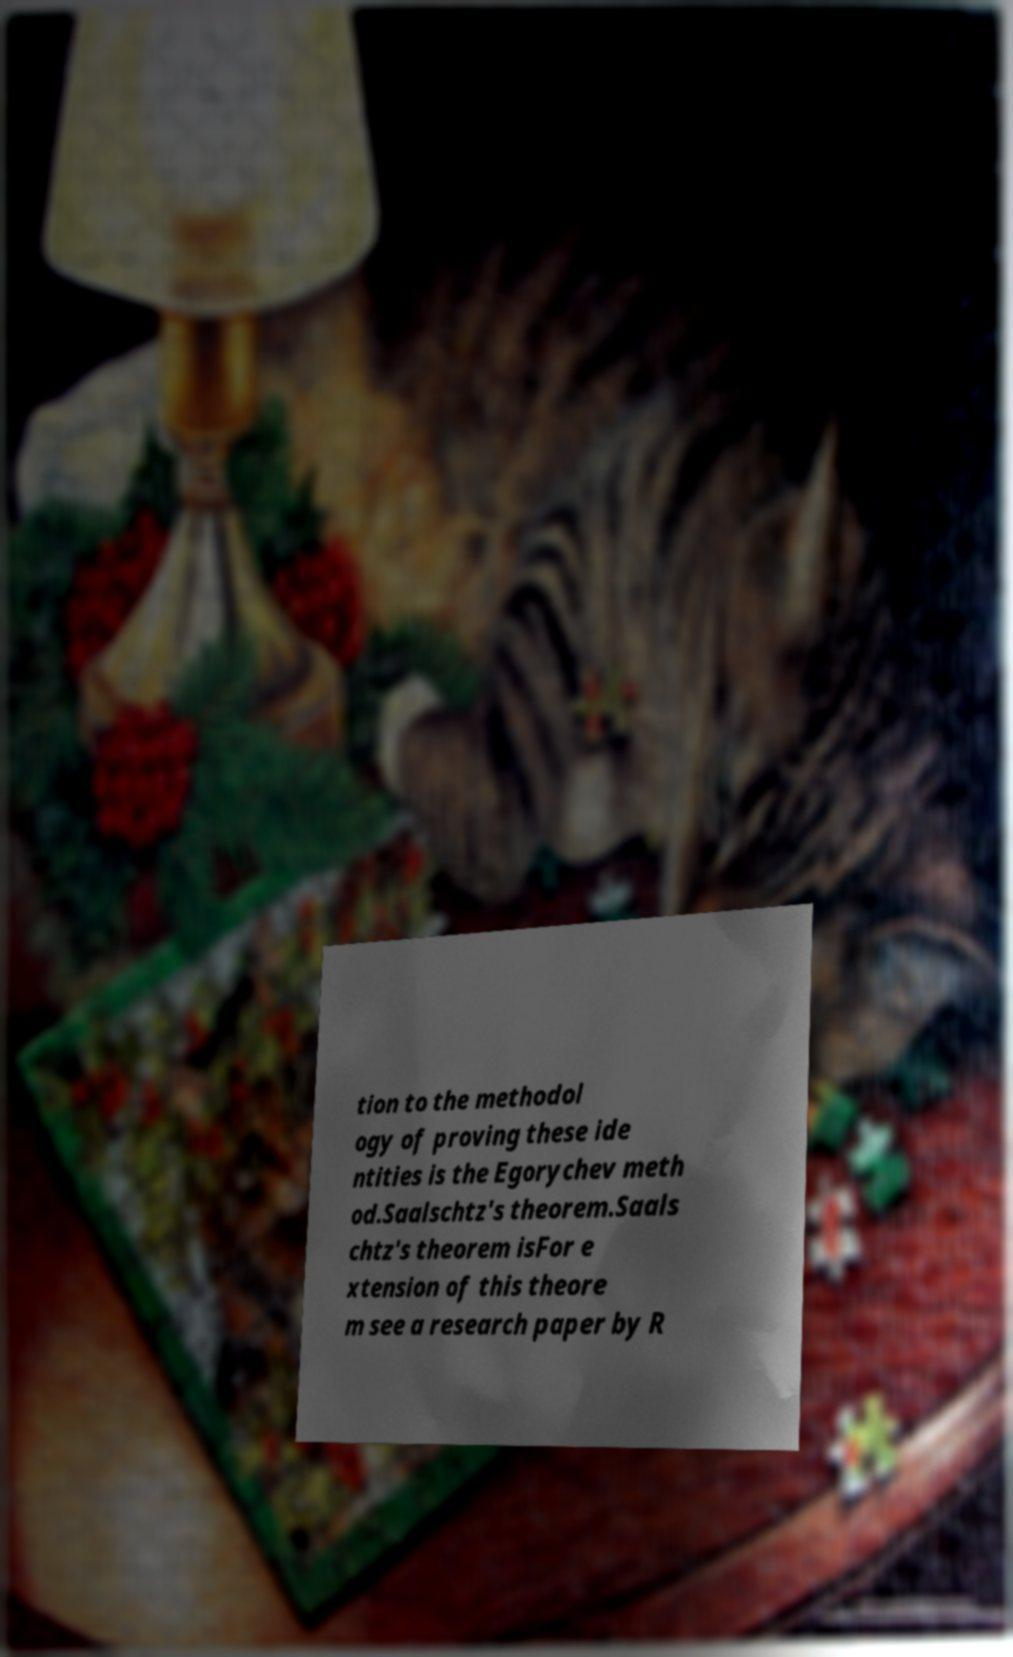What messages or text are displayed in this image? I need them in a readable, typed format. tion to the methodol ogy of proving these ide ntities is the Egorychev meth od.Saalschtz's theorem.Saals chtz's theorem isFor e xtension of this theore m see a research paper by R 